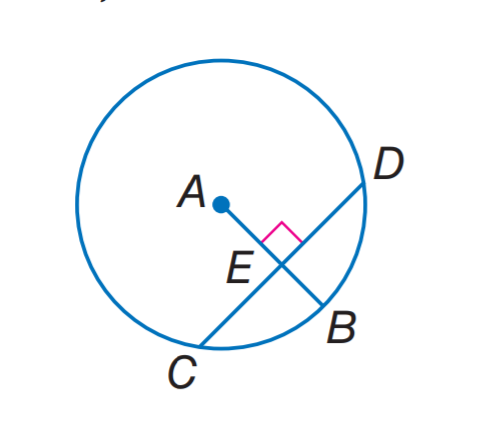Question: In A, the radius is 14 and C D = 22. Find C E.
Choices:
A. 7
B. 11
C. 14
D. 22
Answer with the letter. Answer: B Question: In A, the radius is 14 and C D = 22. Find E B. Round to the nearest hundredth.
Choices:
A. 3.72
B. 5.34
C. 8.66
D. 16.97
Answer with the letter. Answer: B 